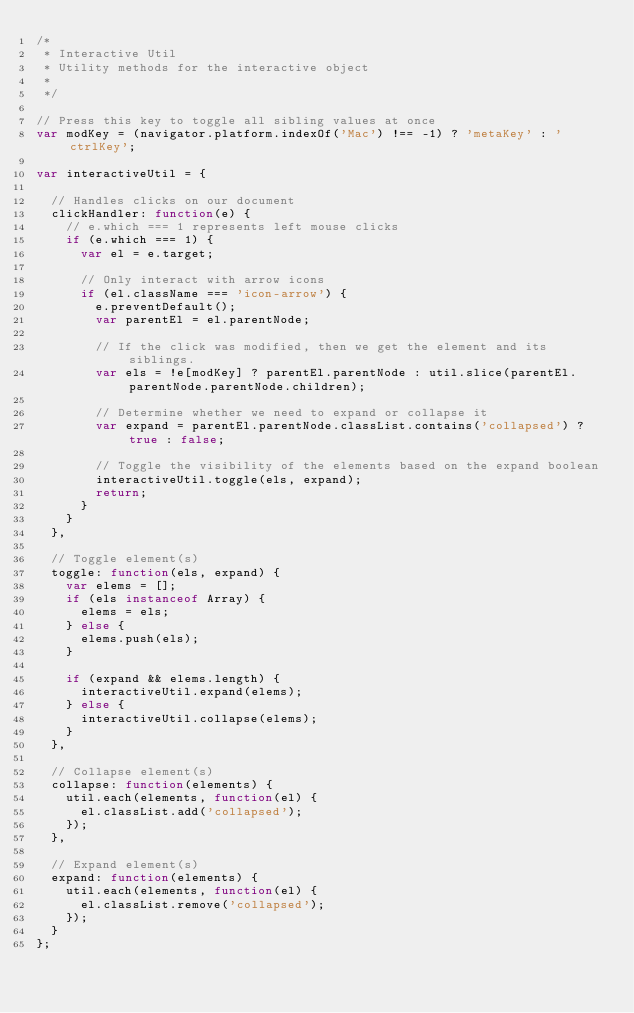<code> <loc_0><loc_0><loc_500><loc_500><_JavaScript_>/*
 * Interactive Util
 * Utility methods for the interactive object
 *
 */

// Press this key to toggle all sibling values at once
var modKey = (navigator.platform.indexOf('Mac') !== -1) ? 'metaKey' : 'ctrlKey';

var interactiveUtil = {

  // Handles clicks on our document
  clickHandler: function(e) {
    // e.which === 1 represents left mouse clicks
    if (e.which === 1) {
      var el = e.target;

      // Only interact with arrow icons
      if (el.className === 'icon-arrow') {
        e.preventDefault();
        var parentEl = el.parentNode;

        // If the click was modified, then we get the element and its siblings.
        var els = !e[modKey] ? parentEl.parentNode : util.slice(parentEl.parentNode.parentNode.children);

        // Determine whether we need to expand or collapse it
        var expand = parentEl.parentNode.classList.contains('collapsed') ? true : false;

        // Toggle the visibility of the elements based on the expand boolean
        interactiveUtil.toggle(els, expand);
        return;
      }
    }
  },

  // Toggle element(s)
  toggle: function(els, expand) {
    var elems = [];
    if (els instanceof Array) {
      elems = els;
    } else {
      elems.push(els);
    }

    if (expand && elems.length) {
      interactiveUtil.expand(elems);
    } else {
      interactiveUtil.collapse(elems);
    }
  },

  // Collapse element(s)
  collapse: function(elements) {
    util.each(elements, function(el) {
      el.classList.add('collapsed');
    });
  },

  // Expand element(s)
  expand: function(elements) {
    util.each(elements, function(el) {
      el.classList.remove('collapsed');
    });
  }
};
</code> 